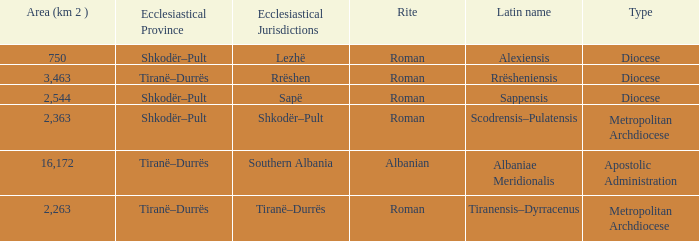What Area (km 2) is lowest with a type being Apostolic Administration? 16172.0. 